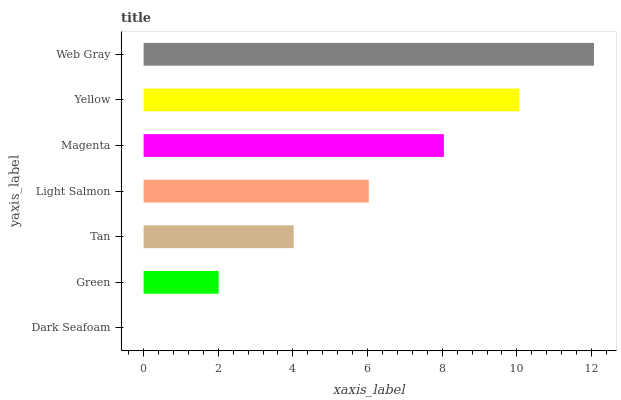Is Dark Seafoam the minimum?
Answer yes or no. Yes. Is Web Gray the maximum?
Answer yes or no. Yes. Is Green the minimum?
Answer yes or no. No. Is Green the maximum?
Answer yes or no. No. Is Green greater than Dark Seafoam?
Answer yes or no. Yes. Is Dark Seafoam less than Green?
Answer yes or no. Yes. Is Dark Seafoam greater than Green?
Answer yes or no. No. Is Green less than Dark Seafoam?
Answer yes or no. No. Is Light Salmon the high median?
Answer yes or no. Yes. Is Light Salmon the low median?
Answer yes or no. Yes. Is Tan the high median?
Answer yes or no. No. Is Green the low median?
Answer yes or no. No. 